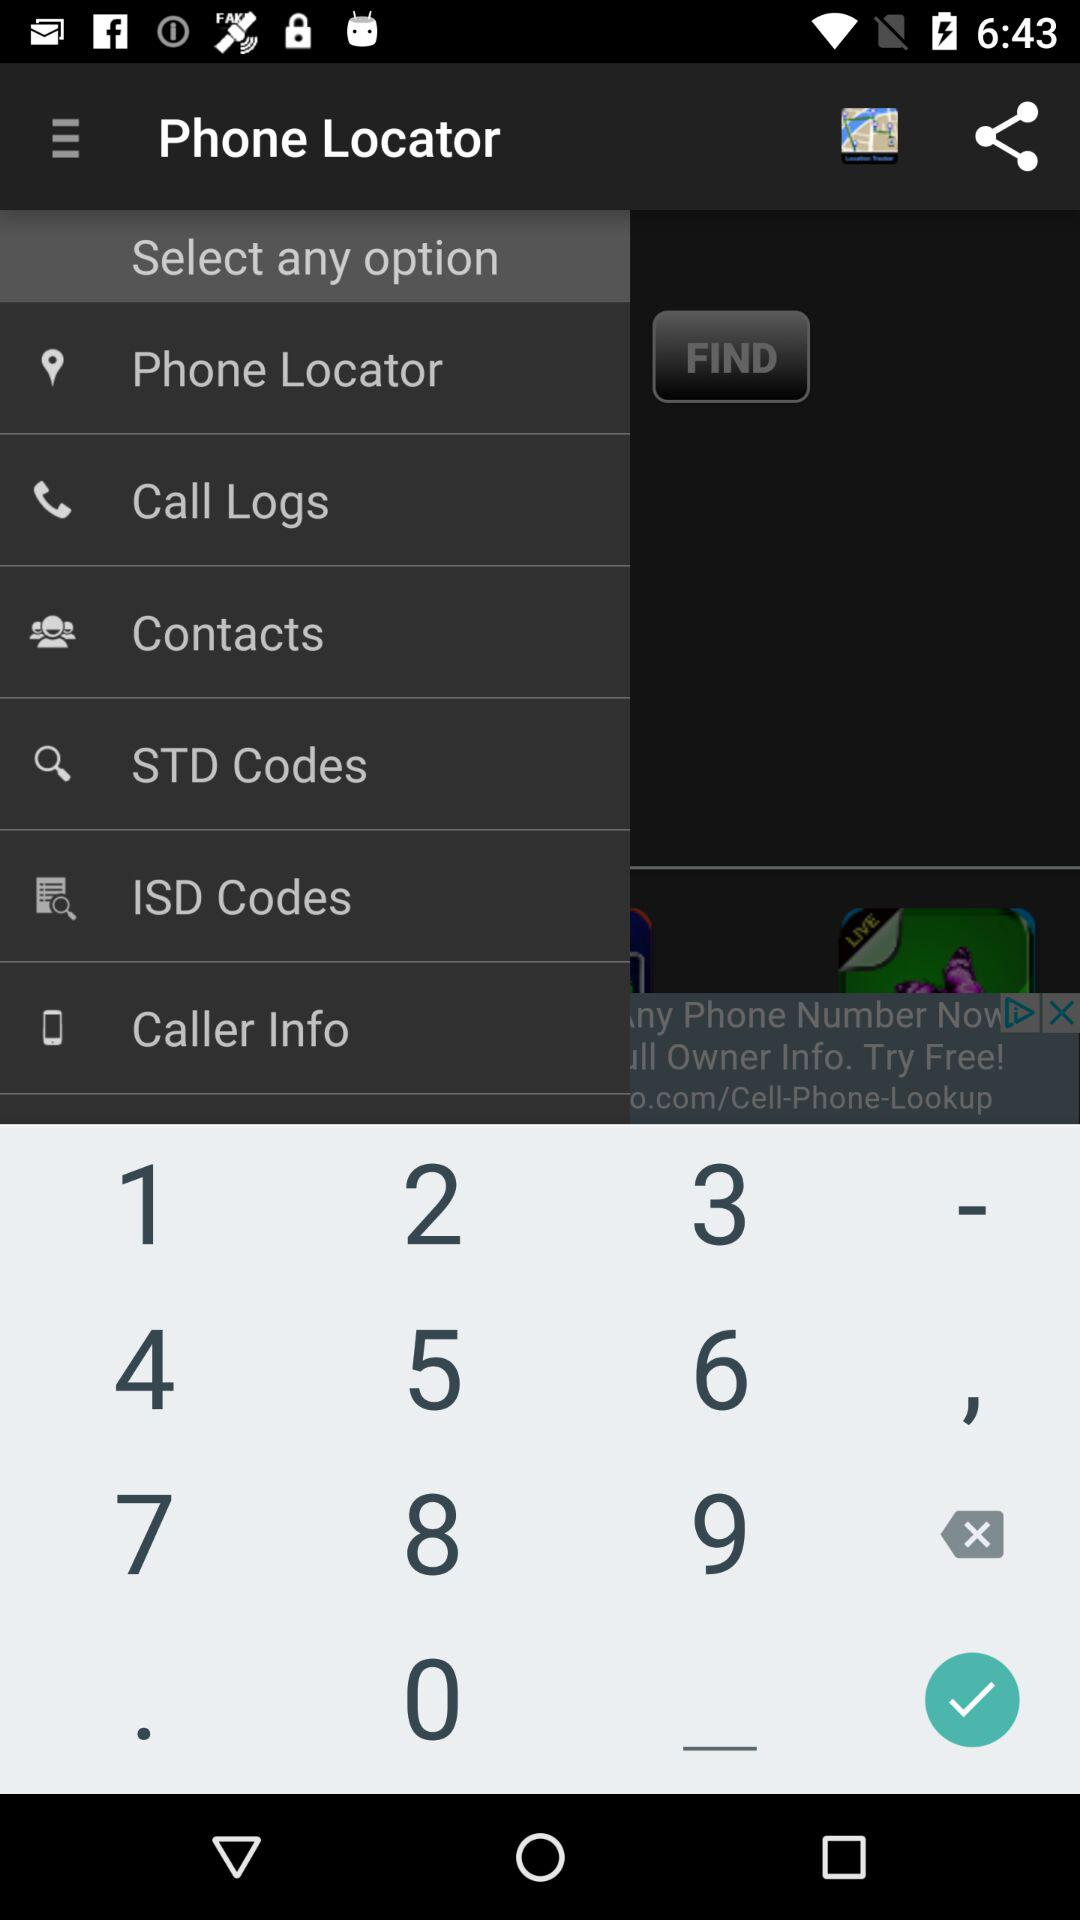What is the name of the application? The name of the application is "Phone Locator". 